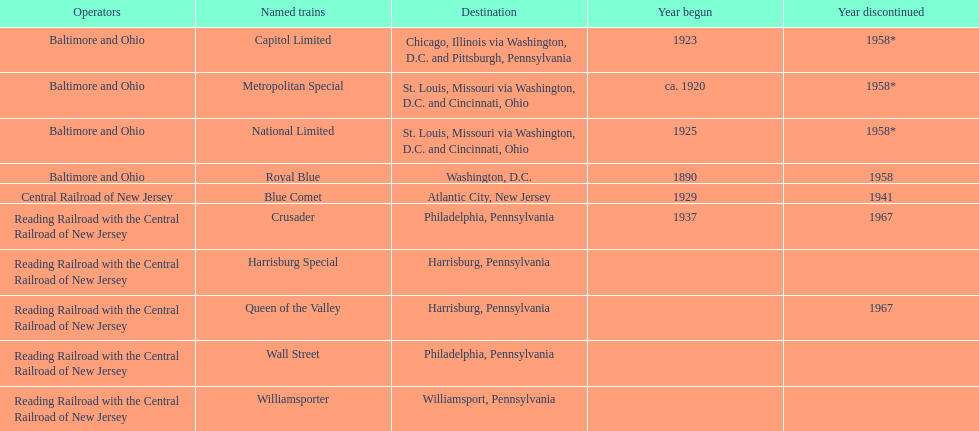What is the difference (in years) between when the royal blue began and the year the crusader began? 47. 